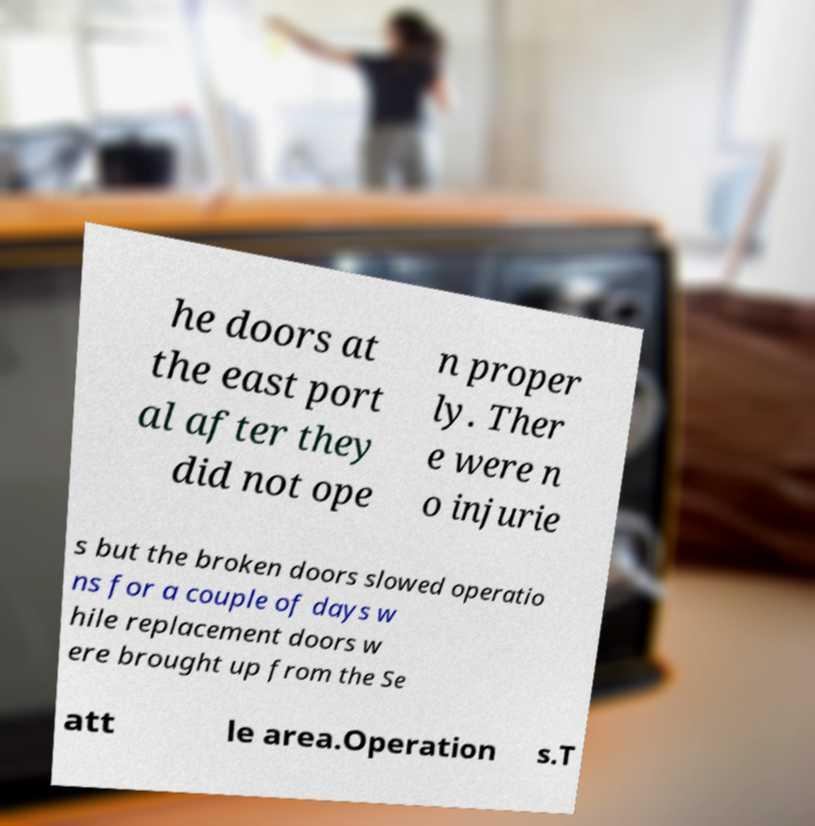For documentation purposes, I need the text within this image transcribed. Could you provide that? he doors at the east port al after they did not ope n proper ly. Ther e were n o injurie s but the broken doors slowed operatio ns for a couple of days w hile replacement doors w ere brought up from the Se att le area.Operation s.T 